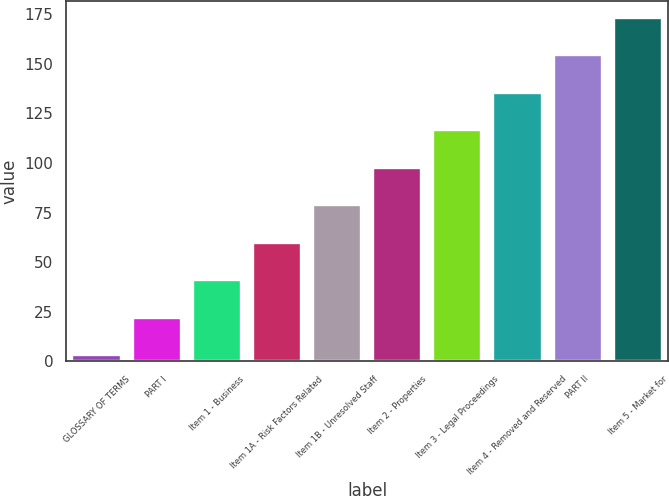Convert chart. <chart><loc_0><loc_0><loc_500><loc_500><bar_chart><fcel>GLOSSARY OF TERMS<fcel>PART I<fcel>Item 1 - Business<fcel>Item 1A - Risk Factors Related<fcel>Item 1B - Unresolved Staff<fcel>Item 2 - Properties<fcel>Item 3 - Legal Proceedings<fcel>Item 4 - Removed and Reserved<fcel>PART II<fcel>Item 5 - Market for<nl><fcel>3<fcel>21.9<fcel>40.8<fcel>59.7<fcel>78.6<fcel>97.5<fcel>116.4<fcel>135.3<fcel>154.2<fcel>173.1<nl></chart> 